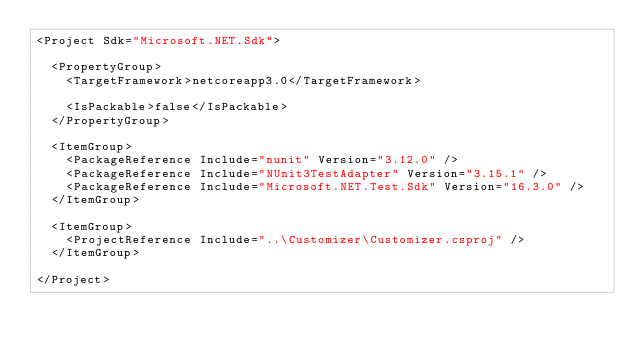<code> <loc_0><loc_0><loc_500><loc_500><_XML_><Project Sdk="Microsoft.NET.Sdk">

  <PropertyGroup>
    <TargetFramework>netcoreapp3.0</TargetFramework>

    <IsPackable>false</IsPackable>
  </PropertyGroup>

  <ItemGroup>
    <PackageReference Include="nunit" Version="3.12.0" />
    <PackageReference Include="NUnit3TestAdapter" Version="3.15.1" />
    <PackageReference Include="Microsoft.NET.Test.Sdk" Version="16.3.0" />
  </ItemGroup>

  <ItemGroup>
    <ProjectReference Include="..\Customizer\Customizer.csproj" />
  </ItemGroup>

</Project>
</code> 